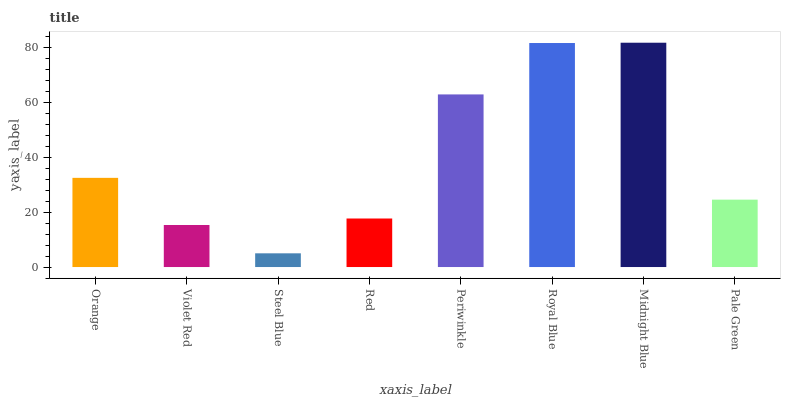Is Steel Blue the minimum?
Answer yes or no. Yes. Is Midnight Blue the maximum?
Answer yes or no. Yes. Is Violet Red the minimum?
Answer yes or no. No. Is Violet Red the maximum?
Answer yes or no. No. Is Orange greater than Violet Red?
Answer yes or no. Yes. Is Violet Red less than Orange?
Answer yes or no. Yes. Is Violet Red greater than Orange?
Answer yes or no. No. Is Orange less than Violet Red?
Answer yes or no. No. Is Orange the high median?
Answer yes or no. Yes. Is Pale Green the low median?
Answer yes or no. Yes. Is Violet Red the high median?
Answer yes or no. No. Is Steel Blue the low median?
Answer yes or no. No. 